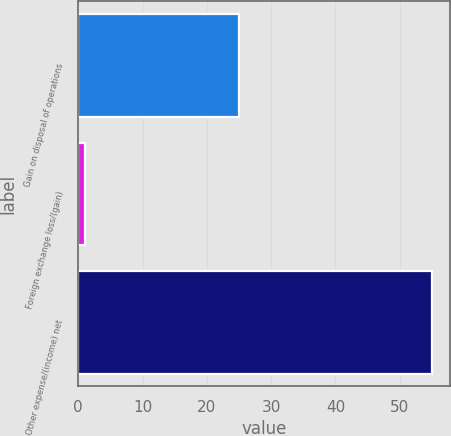Convert chart to OTSL. <chart><loc_0><loc_0><loc_500><loc_500><bar_chart><fcel>Gain on disposal of operations<fcel>Foreign exchange loss/(gain)<fcel>Other expense/(income) net<nl><fcel>25<fcel>1<fcel>55<nl></chart> 